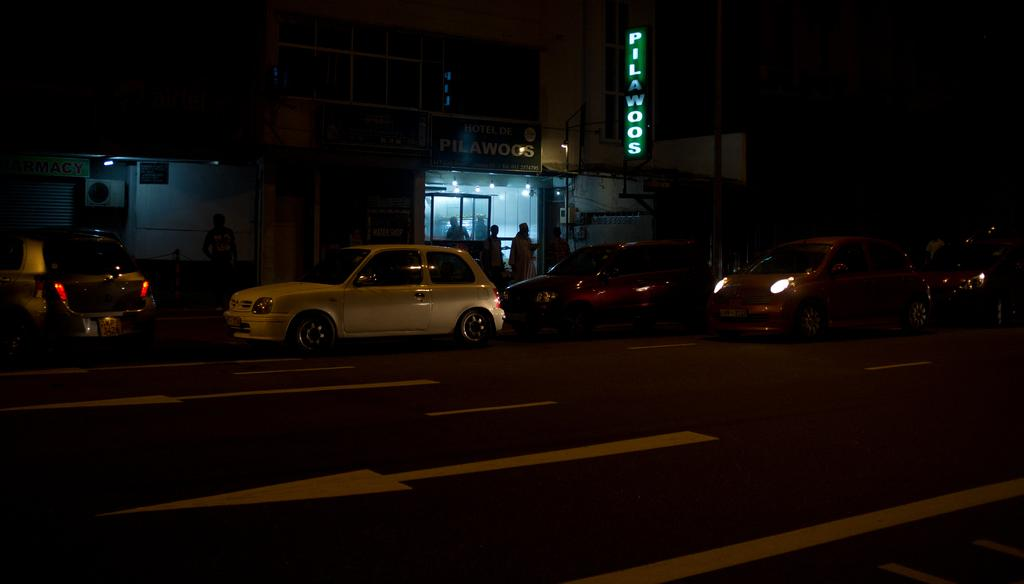What is happening in the image? There are vehicles moving on a road in the image. What can be seen in the distance? There is a building in the background of the image. Are there any people visible in the image? Yes, there are people standing near the building in the background. What type of rod is being used by the people near the building in the image? There is no rod visible in the image; the people are simply standing near the building. 